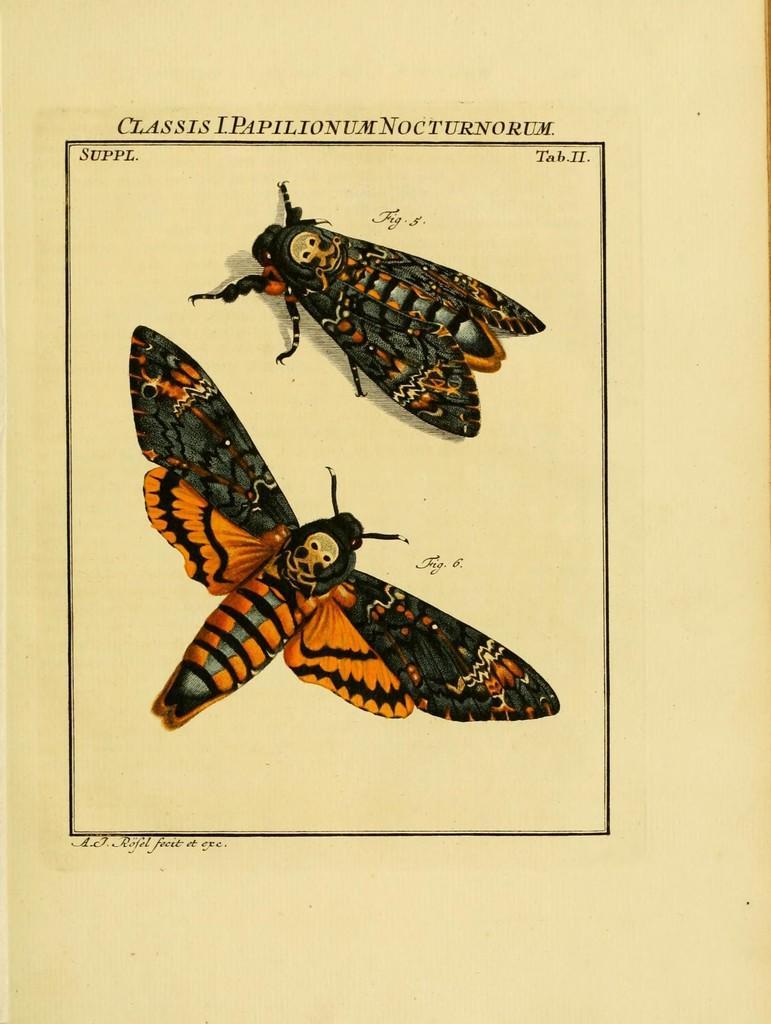Could you give a brief overview of what you see in this image? In the given image i can see a death's head hawkmoth and some text on it. 